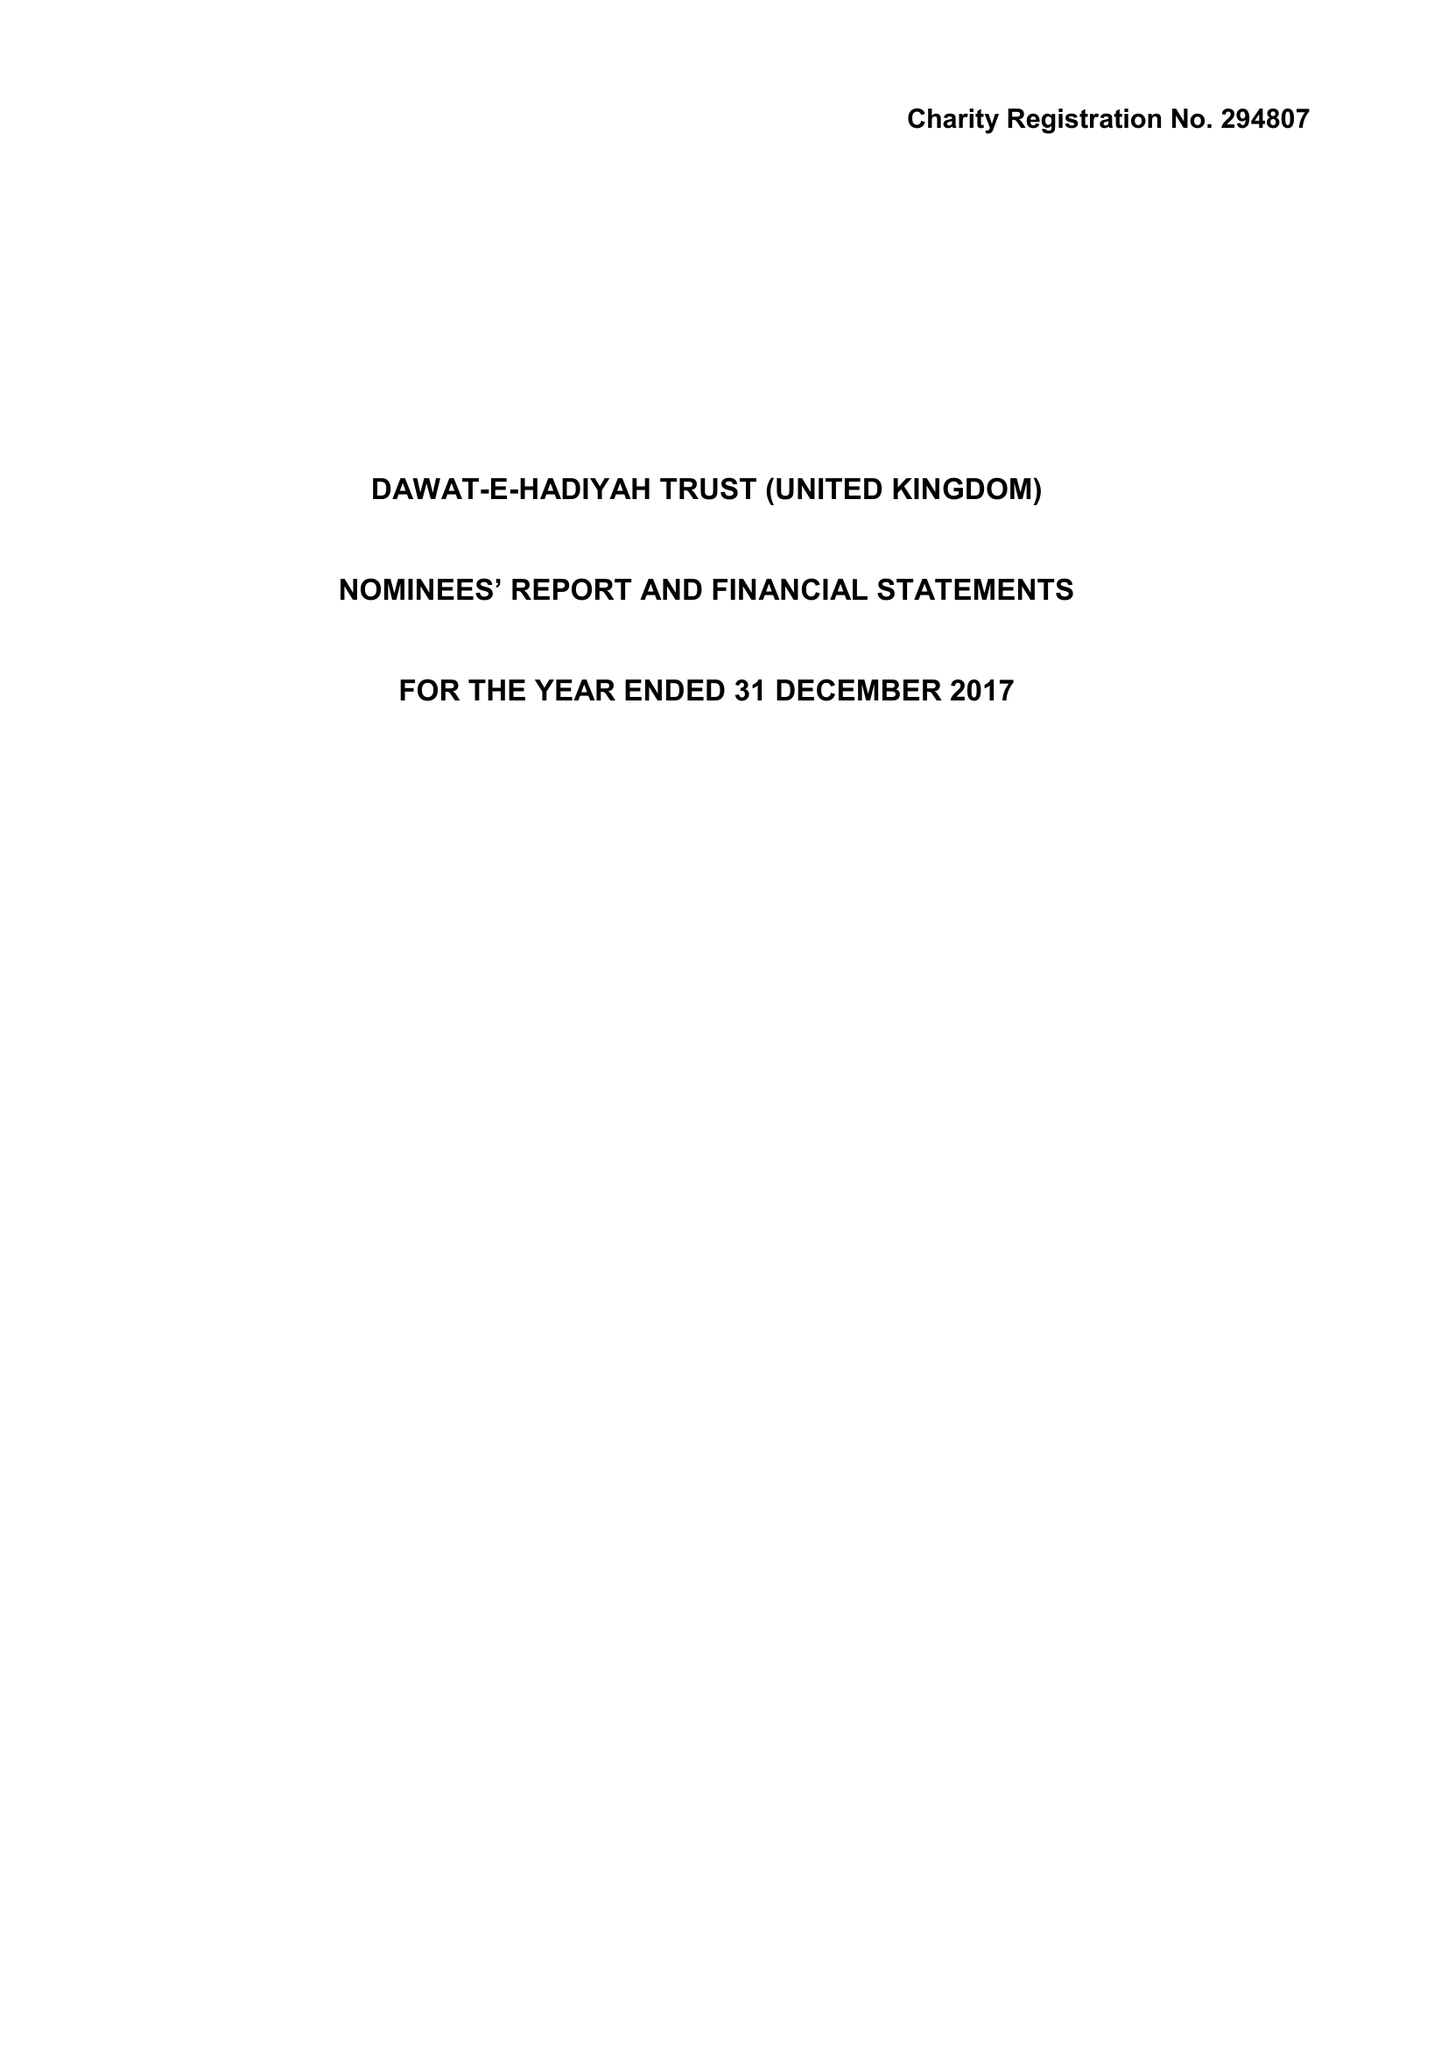What is the value for the charity_number?
Answer the question using a single word or phrase. 294807 